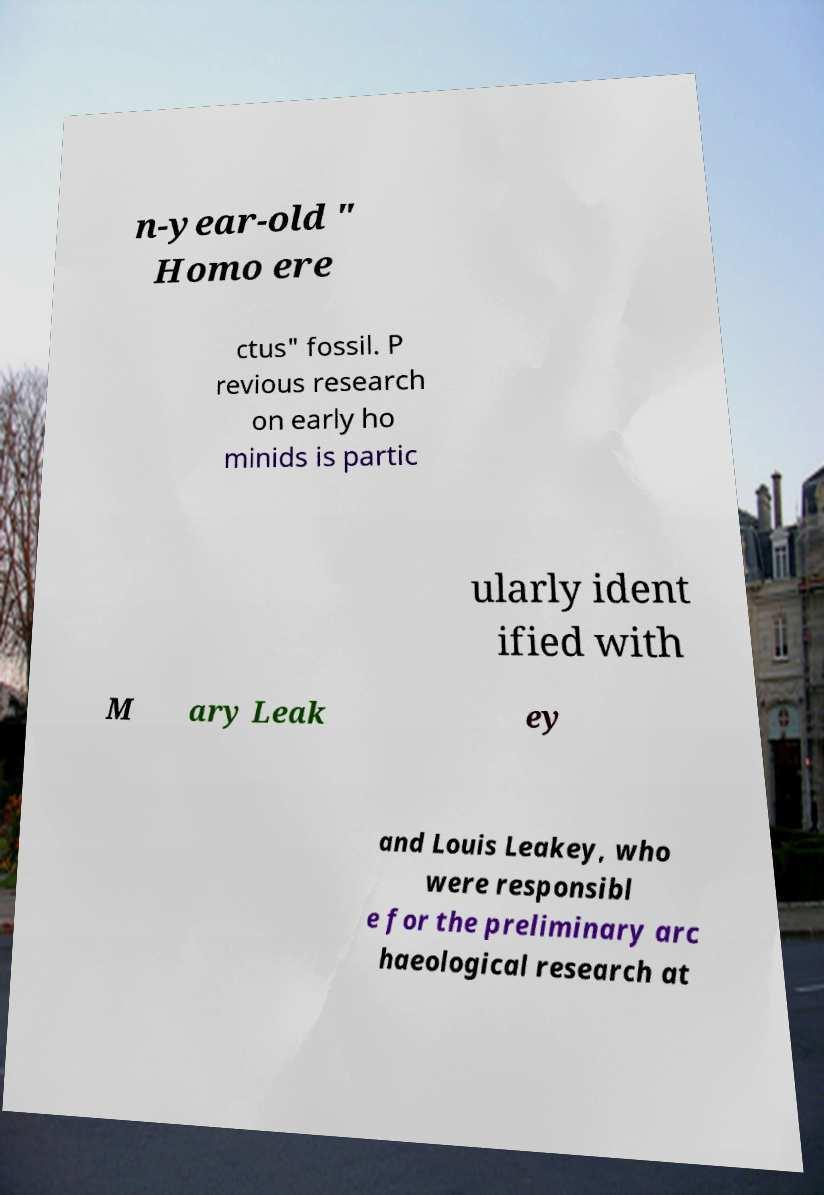Could you assist in decoding the text presented in this image and type it out clearly? n-year-old " Homo ere ctus" fossil. P revious research on early ho minids is partic ularly ident ified with M ary Leak ey and Louis Leakey, who were responsibl e for the preliminary arc haeological research at 